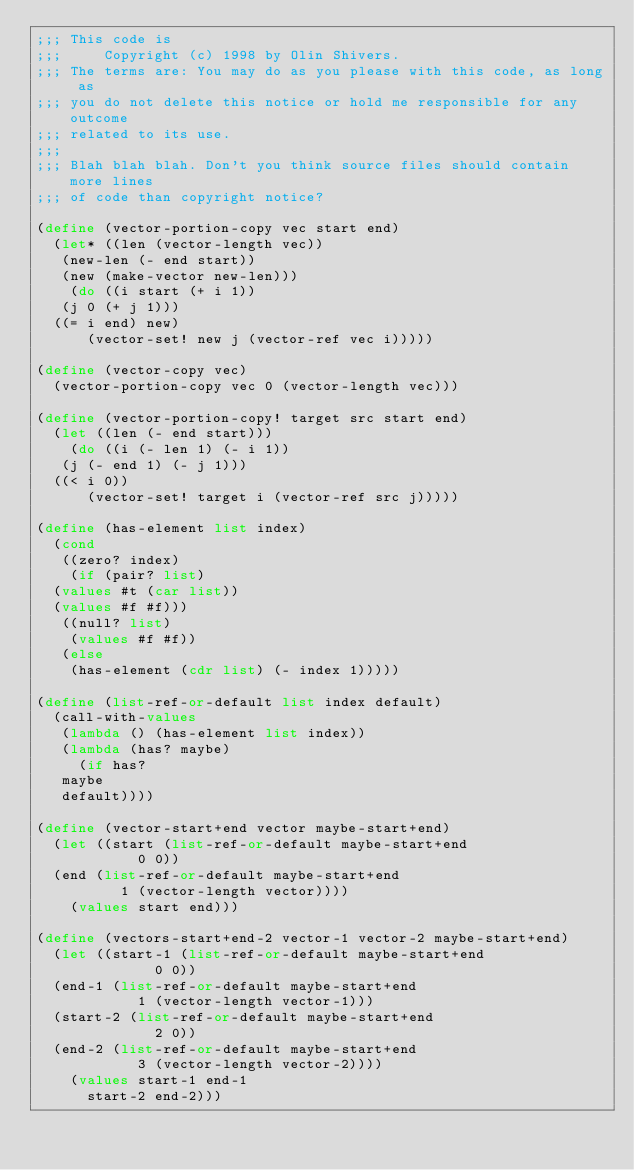Convert code to text. <code><loc_0><loc_0><loc_500><loc_500><_Scheme_>;;; This code is
;;;     Copyright (c) 1998 by Olin Shivers.
;;; The terms are: You may do as you please with this code, as long as
;;; you do not delete this notice or hold me responsible for any outcome
;;; related to its use.
;;;
;;; Blah blah blah. Don't you think source files should contain more lines
;;; of code than copyright notice?

(define (vector-portion-copy vec start end)
  (let* ((len (vector-length vec))
	 (new-len (- end start))
	 (new (make-vector new-len)))
    (do ((i start (+ i 1))
	 (j 0 (+ j 1)))
	((= i end) new)
      (vector-set! new j (vector-ref vec i)))))

(define (vector-copy vec)
  (vector-portion-copy vec 0 (vector-length vec)))

(define (vector-portion-copy! target src start end)
  (let ((len (- end start)))
    (do ((i (- len 1) (- i 1))
	 (j (- end 1) (- j 1)))
	((< i 0))
      (vector-set! target i (vector-ref src j)))))

(define (has-element list index)
  (cond
   ((zero? index)
    (if (pair? list)
	(values #t (car list))
	(values #f #f)))
   ((null? list)
    (values #f #f))
   (else
    (has-element (cdr list) (- index 1)))))

(define (list-ref-or-default list index default)
  (call-with-values
   (lambda () (has-element list index))
   (lambda (has? maybe)
     (if has?
	 maybe
	 default))))

(define (vector-start+end vector maybe-start+end)
  (let ((start (list-ref-or-default maybe-start+end
				    0 0))
	(end (list-ref-or-default maybe-start+end
				  1 (vector-length vector))))
    (values start end)))

(define (vectors-start+end-2 vector-1 vector-2 maybe-start+end)
  (let ((start-1 (list-ref-or-default maybe-start+end
				      0 0))
	(end-1 (list-ref-or-default maybe-start+end
				    1 (vector-length vector-1)))
	(start-2 (list-ref-or-default maybe-start+end
				      2 0))
	(end-2 (list-ref-or-default maybe-start+end
				    3 (vector-length vector-2))))
    (values start-1 end-1
	    start-2 end-2)))
</code> 